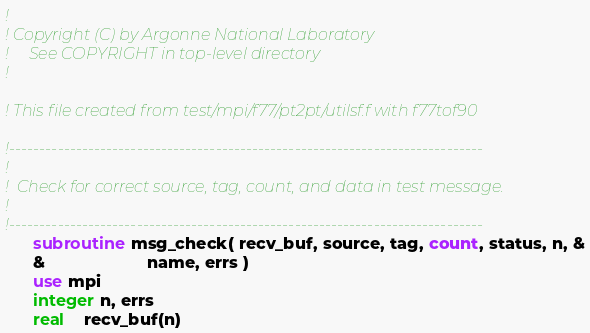Convert code to text. <code><loc_0><loc_0><loc_500><loc_500><_FORTRAN_>!
! Copyright (C) by Argonne National Laboratory
!     See COPYRIGHT in top-level directory
!

! This file created from test/mpi/f77/pt2pt/utilsf.f with f77tof90

!------------------------------------------------------------------------------
!
!  Check for correct source, tag, count, and data in test message.
!
!------------------------------------------------------------------------------
      subroutine msg_check( recv_buf, source, tag, count, status, n, &
      &                      name, errs )
      use mpi
      integer n, errs
      real    recv_buf(n)</code> 